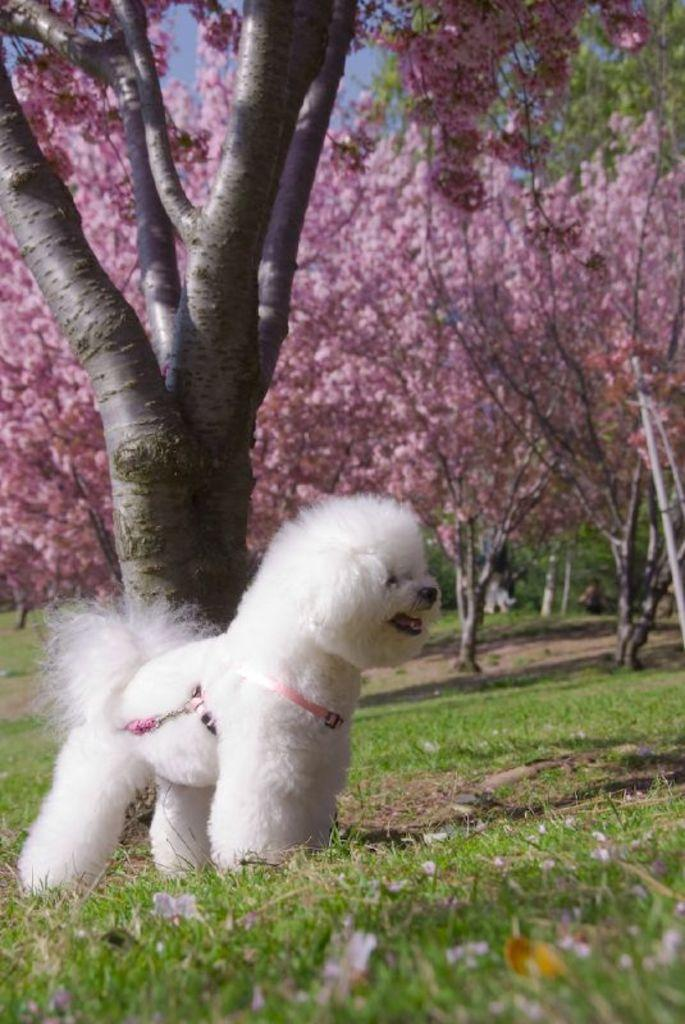What animal can be seen in the image? There is a dog in the image. Where is the dog located? The dog is on the grass. What can be seen in the background of the image? There are many trees in the background of the image. What part of the natural environment is visible in the image? The sky is visible in the image. How many dimes can be seen on the street in the image? There is no street or dimes present in the image; it features a dog on the grass with trees and sky in the background. 